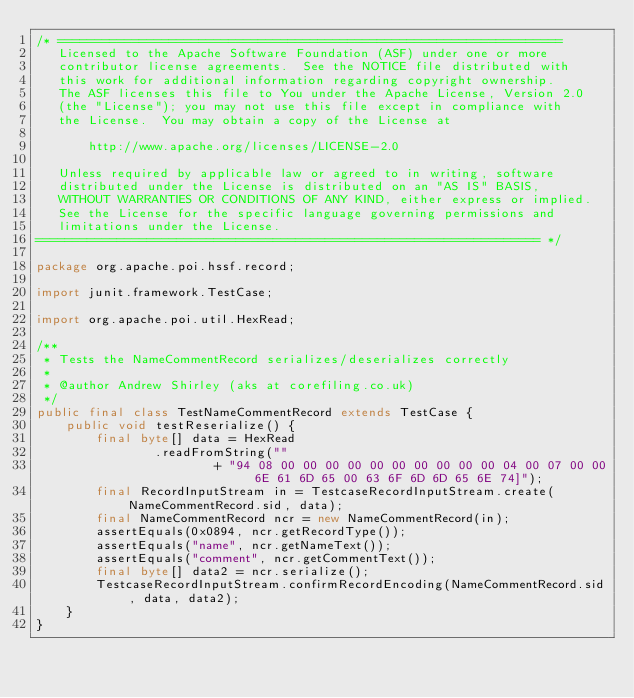<code> <loc_0><loc_0><loc_500><loc_500><_Java_>/* ====================================================================
   Licensed to the Apache Software Foundation (ASF) under one or more
   contributor license agreements.  See the NOTICE file distributed with
   this work for additional information regarding copyright ownership.
   The ASF licenses this file to You under the Apache License, Version 2.0
   (the "License"); you may not use this file except in compliance with
   the License.  You may obtain a copy of the License at

       http://www.apache.org/licenses/LICENSE-2.0

   Unless required by applicable law or agreed to in writing, software
   distributed under the License is distributed on an "AS IS" BASIS,
   WITHOUT WARRANTIES OR CONDITIONS OF ANY KIND, either express or implied.
   See the License for the specific language governing permissions and
   limitations under the License.
==================================================================== */

package org.apache.poi.hssf.record;

import junit.framework.TestCase;

import org.apache.poi.util.HexRead;

/**
 * Tests the NameCommentRecord serializes/deserializes correctly
 *
 * @author Andrew Shirley (aks at corefiling.co.uk)
 */
public final class TestNameCommentRecord extends TestCase {
	public void testReserialize() {
		final byte[] data = HexRead
				.readFromString(""
						+ "94 08 00 00 00 00 00 00 00 00 00 00 04 00 07 00 00 6E 61 6D 65 00 63 6F 6D 6D 65 6E 74]");
		final RecordInputStream in = TestcaseRecordInputStream.create(NameCommentRecord.sid, data);
		final NameCommentRecord ncr = new NameCommentRecord(in);
		assertEquals(0x0894, ncr.getRecordType());
		assertEquals("name", ncr.getNameText());
		assertEquals("comment", ncr.getCommentText());
		final byte[] data2 = ncr.serialize();
		TestcaseRecordInputStream.confirmRecordEncoding(NameCommentRecord.sid, data, data2);
	}
}
</code> 